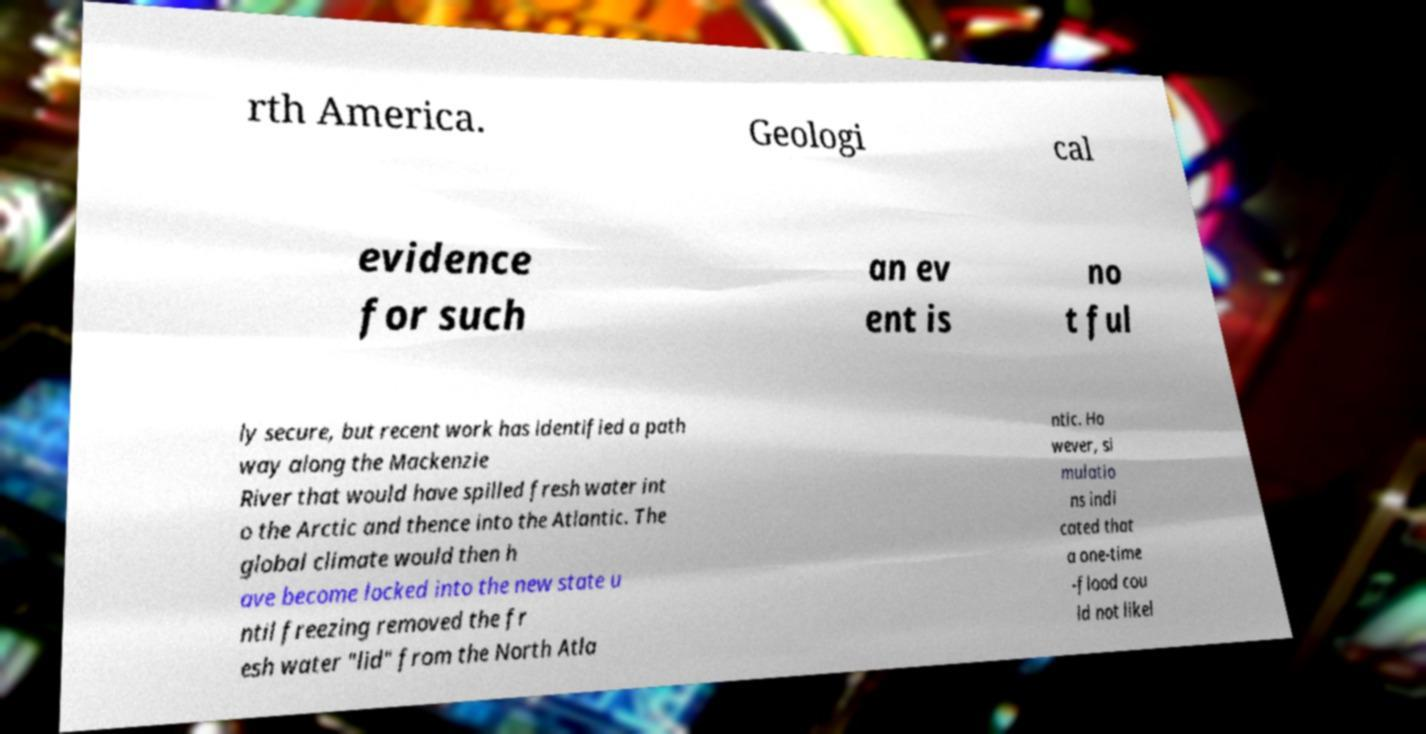I need the written content from this picture converted into text. Can you do that? rth America. Geologi cal evidence for such an ev ent is no t ful ly secure, but recent work has identified a path way along the Mackenzie River that would have spilled fresh water int o the Arctic and thence into the Atlantic. The global climate would then h ave become locked into the new state u ntil freezing removed the fr esh water "lid" from the North Atla ntic. Ho wever, si mulatio ns indi cated that a one-time -flood cou ld not likel 